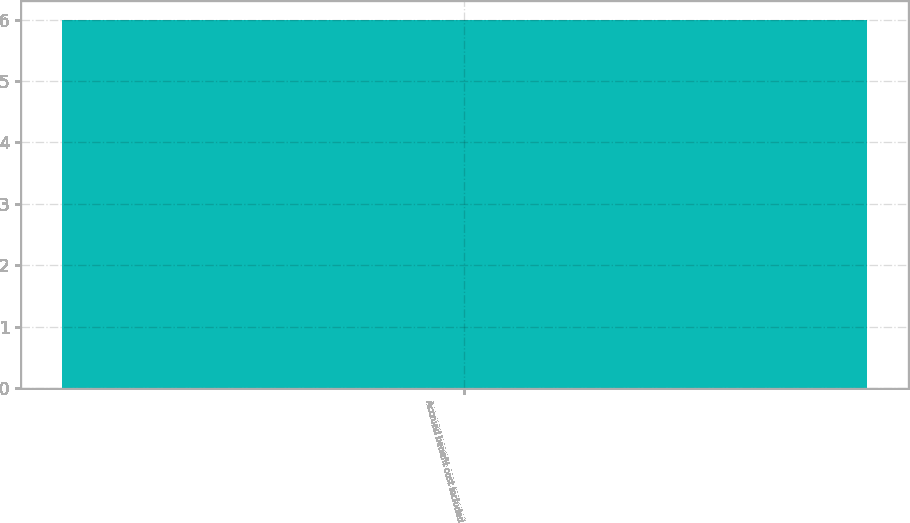<chart> <loc_0><loc_0><loc_500><loc_500><bar_chart><fcel>Accrued benefit cost included<nl><fcel>6<nl></chart> 